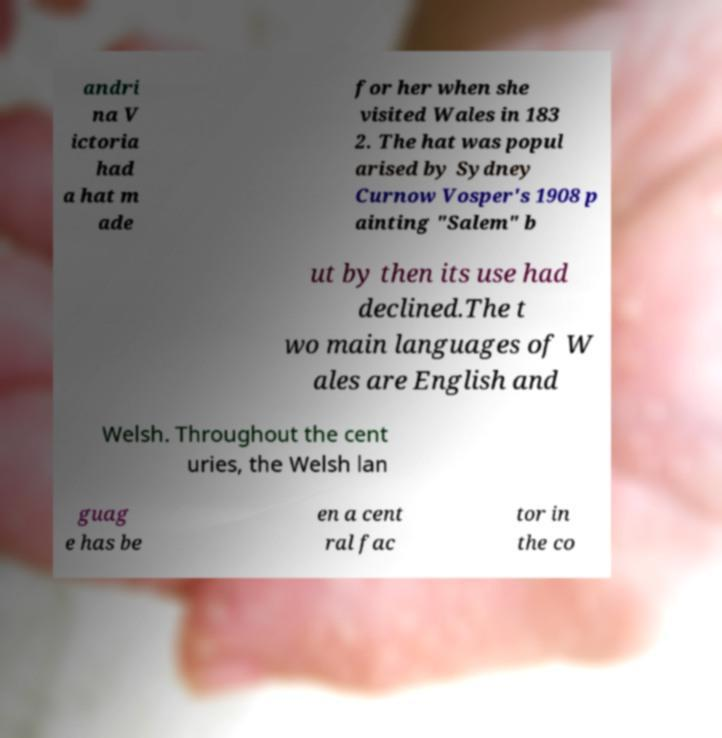For documentation purposes, I need the text within this image transcribed. Could you provide that? andri na V ictoria had a hat m ade for her when she visited Wales in 183 2. The hat was popul arised by Sydney Curnow Vosper's 1908 p ainting "Salem" b ut by then its use had declined.The t wo main languages of W ales are English and Welsh. Throughout the cent uries, the Welsh lan guag e has be en a cent ral fac tor in the co 